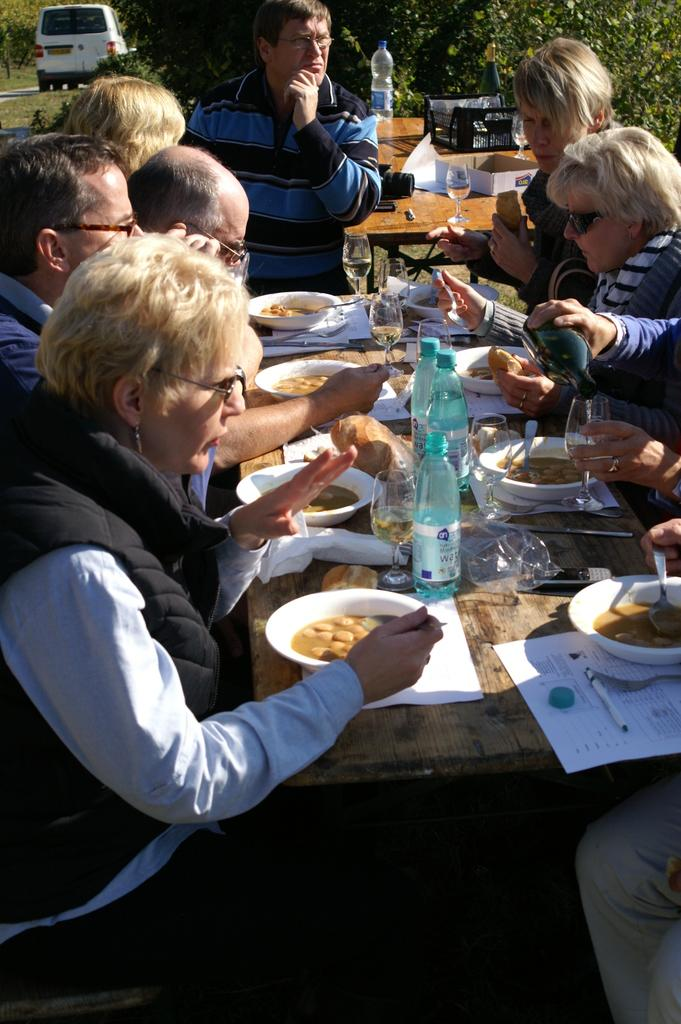How many people are in the image? There is a group of people in the image. What are the people doing in the image? The people are sitting in the image. What is in front of the people? There is a table in front of the people. What activity are the people engaged in? The people are having a meal in the image. What type of baby can be seen playing with a horn in the image? There is no baby or horn present in the image. 